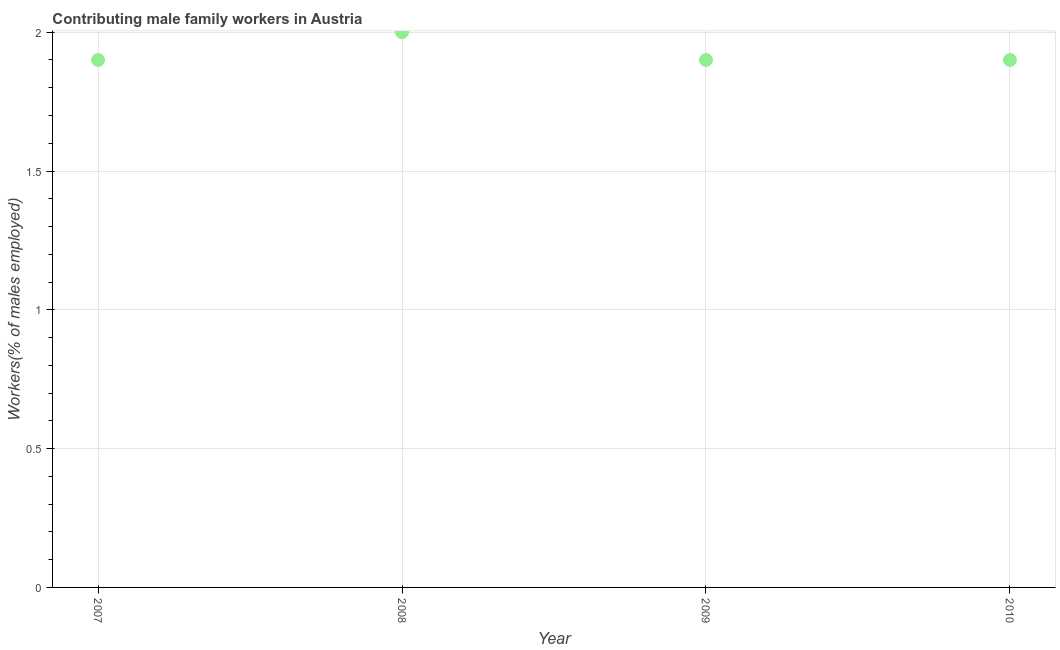What is the contributing male family workers in 2007?
Ensure brevity in your answer.  1.9. Across all years, what is the minimum contributing male family workers?
Your answer should be very brief. 1.9. In which year was the contributing male family workers minimum?
Offer a terse response. 2007. What is the sum of the contributing male family workers?
Your response must be concise. 7.7. What is the difference between the contributing male family workers in 2008 and 2010?
Give a very brief answer. 0.1. What is the average contributing male family workers per year?
Provide a succinct answer. 1.92. What is the median contributing male family workers?
Make the answer very short. 1.9. In how many years, is the contributing male family workers greater than 0.5 %?
Ensure brevity in your answer.  4. Do a majority of the years between 2009 and 2008 (inclusive) have contributing male family workers greater than 0.4 %?
Your response must be concise. No. Is the contributing male family workers in 2007 less than that in 2008?
Your response must be concise. Yes. Is the difference between the contributing male family workers in 2007 and 2009 greater than the difference between any two years?
Ensure brevity in your answer.  No. What is the difference between the highest and the second highest contributing male family workers?
Your answer should be compact. 0.1. What is the difference between the highest and the lowest contributing male family workers?
Your answer should be very brief. 0.1. In how many years, is the contributing male family workers greater than the average contributing male family workers taken over all years?
Offer a very short reply. 1. How many dotlines are there?
Ensure brevity in your answer.  1. What is the difference between two consecutive major ticks on the Y-axis?
Provide a succinct answer. 0.5. Are the values on the major ticks of Y-axis written in scientific E-notation?
Your answer should be compact. No. Does the graph contain any zero values?
Make the answer very short. No. Does the graph contain grids?
Your answer should be compact. Yes. What is the title of the graph?
Make the answer very short. Contributing male family workers in Austria. What is the label or title of the X-axis?
Your answer should be very brief. Year. What is the label or title of the Y-axis?
Ensure brevity in your answer.  Workers(% of males employed). What is the Workers(% of males employed) in 2007?
Give a very brief answer. 1.9. What is the Workers(% of males employed) in 2009?
Ensure brevity in your answer.  1.9. What is the Workers(% of males employed) in 2010?
Your answer should be very brief. 1.9. What is the difference between the Workers(% of males employed) in 2007 and 2009?
Offer a terse response. 0. What is the difference between the Workers(% of males employed) in 2007 and 2010?
Offer a terse response. 0. What is the difference between the Workers(% of males employed) in 2008 and 2010?
Give a very brief answer. 0.1. What is the difference between the Workers(% of males employed) in 2009 and 2010?
Your answer should be very brief. 0. What is the ratio of the Workers(% of males employed) in 2007 to that in 2009?
Offer a terse response. 1. What is the ratio of the Workers(% of males employed) in 2008 to that in 2009?
Offer a terse response. 1.05. What is the ratio of the Workers(% of males employed) in 2008 to that in 2010?
Keep it short and to the point. 1.05. What is the ratio of the Workers(% of males employed) in 2009 to that in 2010?
Provide a short and direct response. 1. 